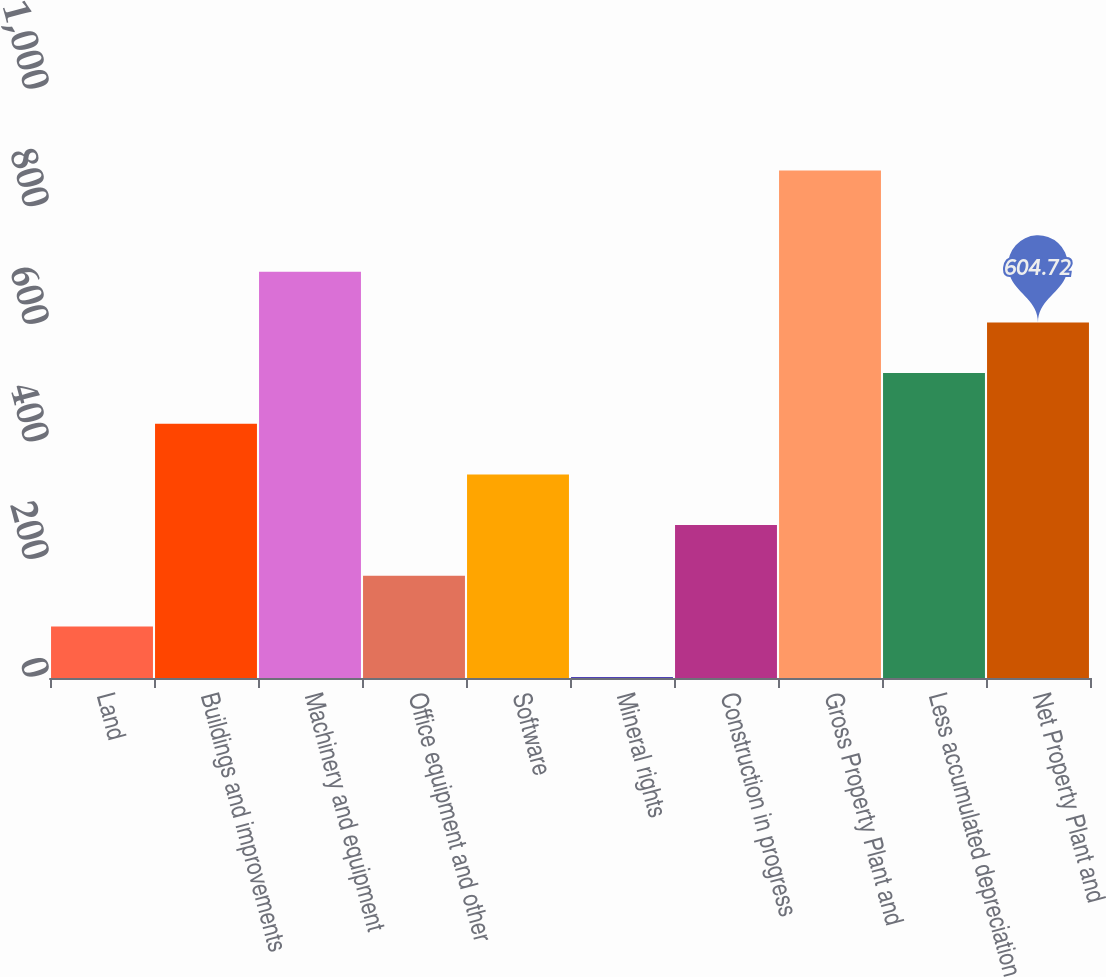Convert chart to OTSL. <chart><loc_0><loc_0><loc_500><loc_500><bar_chart><fcel>Land<fcel>Buildings and improvements<fcel>Machinery and equipment<fcel>Office equipment and other<fcel>Software<fcel>Mineral rights<fcel>Construction in progress<fcel>Gross Property Plant and<fcel>Less accumulated depreciation<fcel>Net Property Plant and<nl><fcel>87.76<fcel>432.4<fcel>690.88<fcel>173.92<fcel>346.24<fcel>1.6<fcel>260.08<fcel>863.2<fcel>518.56<fcel>604.72<nl></chart> 